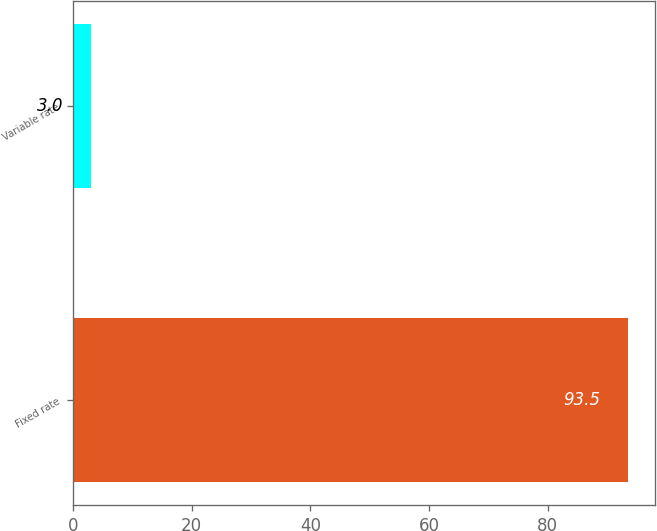<chart> <loc_0><loc_0><loc_500><loc_500><bar_chart><fcel>Fixed rate<fcel>Variable rate<nl><fcel>93.5<fcel>3<nl></chart> 